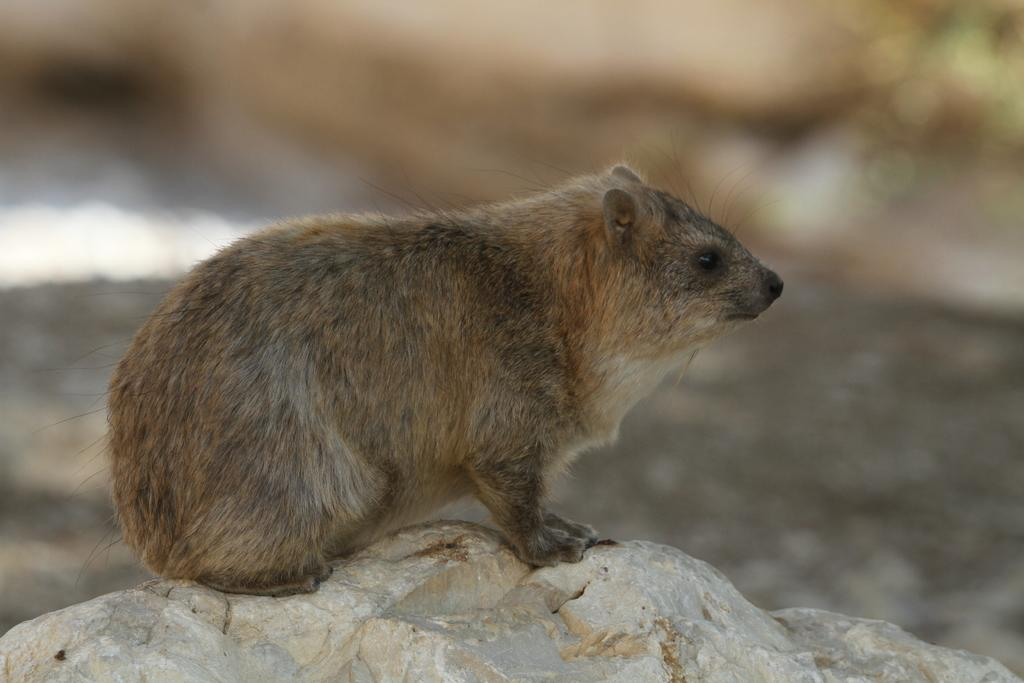What animal is the main subject of the image? There is a groundhog in the image. What surface is the groundhog resting on? The groundhog is on a stone. Can you describe the background of the image? The background of the image is blurred. What type of distribution is the groundhog responsible for in the image? The groundhog is not responsible for any distribution in the image; it is simply an animal resting on a stone. Can you see any rats interacting with the groundhog in the image? There are no rats present in the image. 